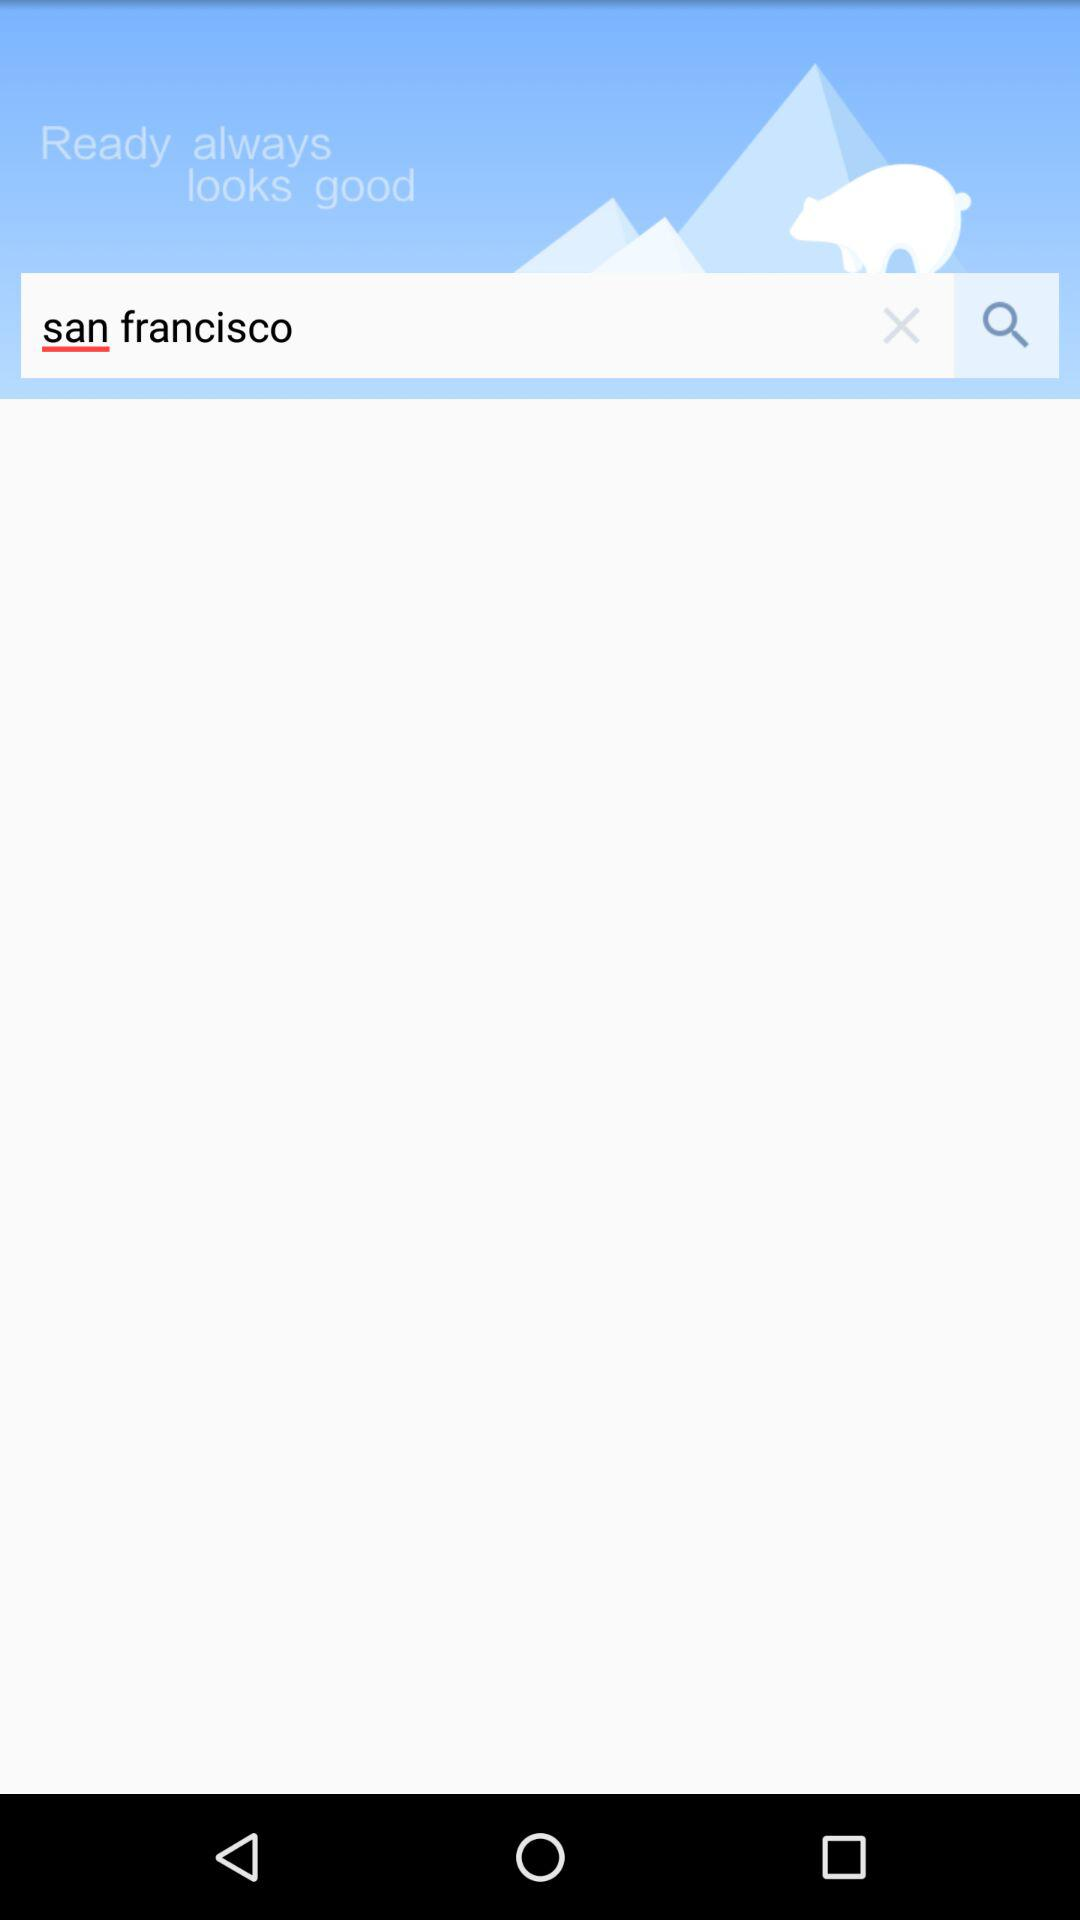Which city's name is in the search bar? The city's name in the search bar is San Francisco. 